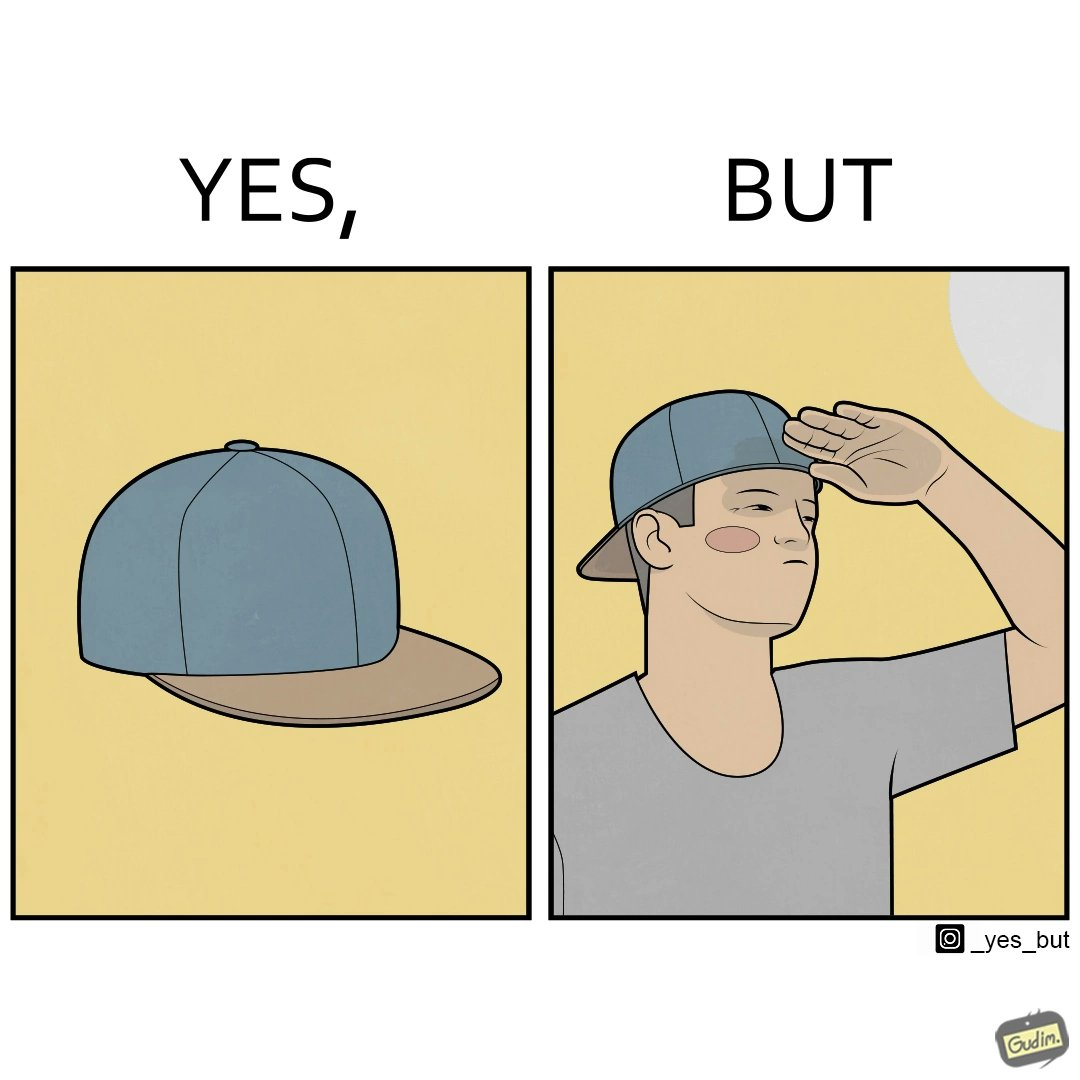Provide a description of this image. This image is funny because a cap is MEANT to protect one's eyes from the sun, but this person is more interested in using it to look stylish, even if it makes them uncomfortable. 